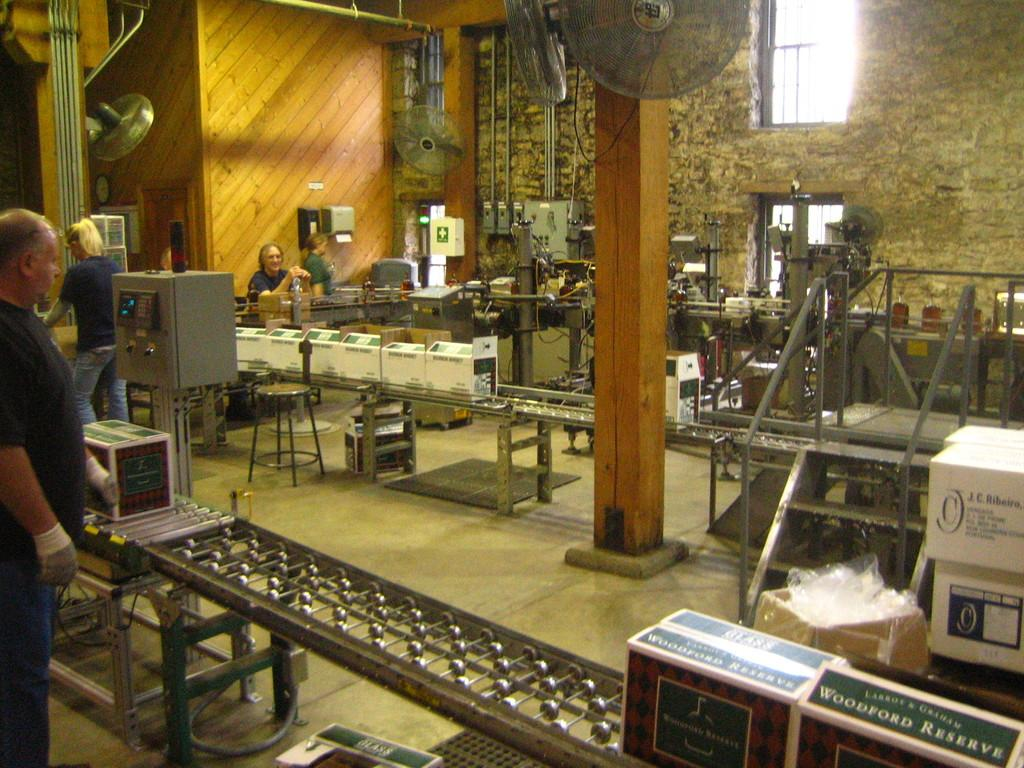Provide a one-sentence caption for the provided image. A wine boxing assembly line featuring Woodford Reserve. 